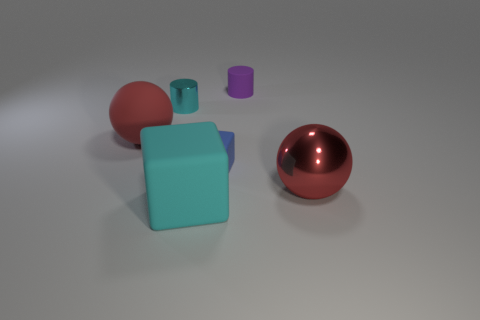Is there a large ball that has the same material as the blue thing?
Your answer should be compact. Yes. There is a big red thing on the right side of the object that is in front of the red thing that is on the right side of the big matte block; what is its shape?
Offer a very short reply. Sphere. Is the size of the cyan metallic thing the same as the ball to the left of the cyan rubber cube?
Provide a succinct answer. No. There is a object that is to the right of the blue rubber block and in front of the big red matte ball; what is its shape?
Ensure brevity in your answer.  Sphere. What number of small things are gray metal blocks or red metallic objects?
Your answer should be very brief. 0. Are there an equal number of cyan rubber objects behind the large shiny thing and small cylinders to the right of the blue thing?
Your answer should be very brief. No. What number of other objects are there of the same color as the small metal object?
Your answer should be compact. 1. Are there an equal number of matte cubes on the left side of the large cyan matte thing and big purple shiny things?
Offer a very short reply. Yes. Do the red matte ball and the purple cylinder have the same size?
Make the answer very short. No. There is a large thing that is left of the tiny blue rubber block and behind the cyan rubber object; what is its material?
Make the answer very short. Rubber. 